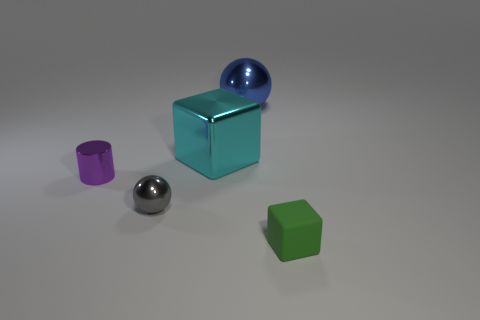What shape is the small shiny thing in front of the thing to the left of the tiny ball?
Keep it short and to the point. Sphere. Are any tiny cyan matte balls visible?
Offer a very short reply. No. What is the color of the block that is behind the cylinder?
Your response must be concise. Cyan. Are there any metallic objects to the right of the gray thing?
Give a very brief answer. Yes. Is the number of brown rubber blocks greater than the number of rubber cubes?
Keep it short and to the point. No. There is a metallic ball that is right of the block that is behind the cylinder behind the small gray metallic object; what color is it?
Make the answer very short. Blue. The small sphere that is the same material as the blue object is what color?
Ensure brevity in your answer.  Gray. How many objects are either rubber things right of the purple shiny cylinder or tiny things that are behind the tiny green matte object?
Ensure brevity in your answer.  3. There is a cube that is to the right of the large cyan metallic block; is its size the same as the block that is behind the green cube?
Keep it short and to the point. No. There is a metallic thing that is the same shape as the small green matte object; what color is it?
Keep it short and to the point. Cyan. 